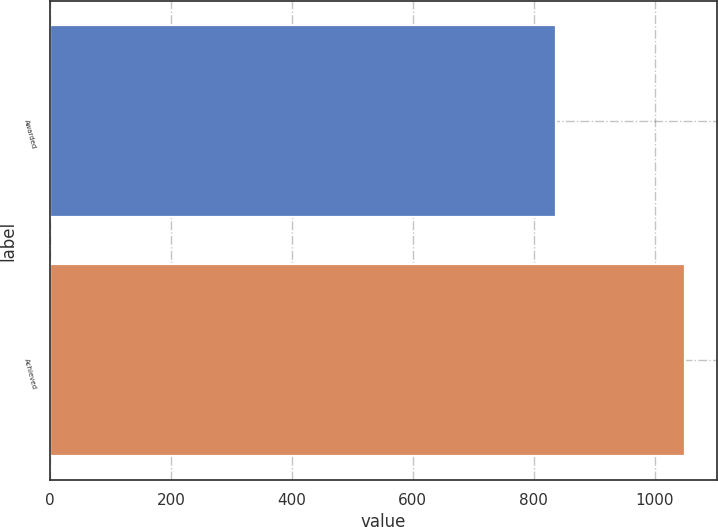<chart> <loc_0><loc_0><loc_500><loc_500><bar_chart><fcel>Awarded<fcel>Achieved<nl><fcel>837<fcel>1050<nl></chart> 